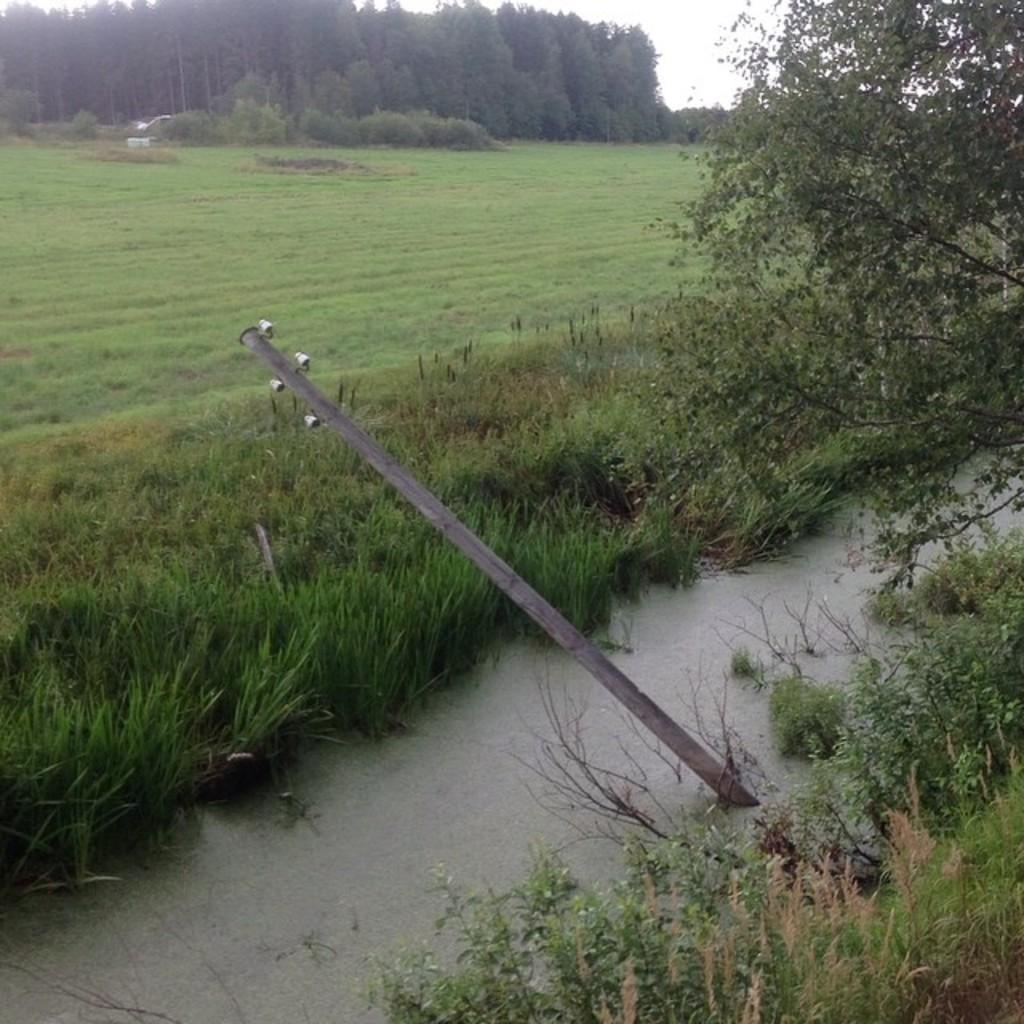What is unusual about the location of the electric pole in the image? The electric pole is in the water, which is not its typical location. What can be seen in the background of the image? There are trees in the background of the image. What type of vegetation is present near the water? There is grass beside the water. What type of ground is visible in the middle of the image? There is ground in the middle of the image with grass on it. What type of underwear is hanging on the electric pole in the image? There is no underwear present in the image; it only features an electric pole in the water. 